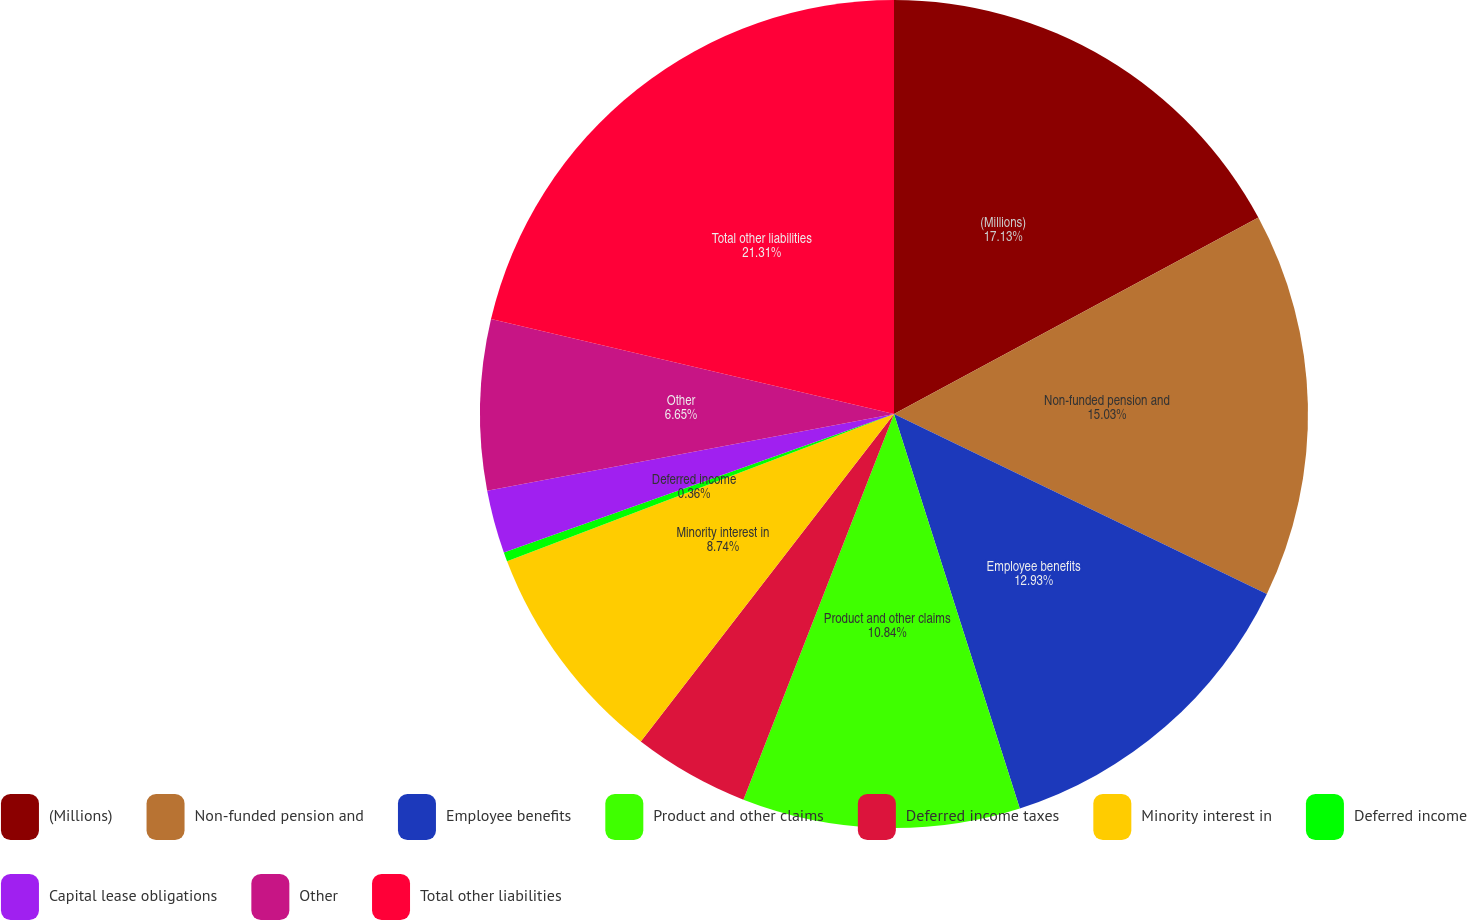Convert chart. <chart><loc_0><loc_0><loc_500><loc_500><pie_chart><fcel>(Millions)<fcel>Non-funded pension and<fcel>Employee benefits<fcel>Product and other claims<fcel>Deferred income taxes<fcel>Minority interest in<fcel>Deferred income<fcel>Capital lease obligations<fcel>Other<fcel>Total other liabilities<nl><fcel>17.13%<fcel>15.03%<fcel>12.93%<fcel>10.84%<fcel>4.55%<fcel>8.74%<fcel>0.36%<fcel>2.46%<fcel>6.65%<fcel>21.32%<nl></chart> 